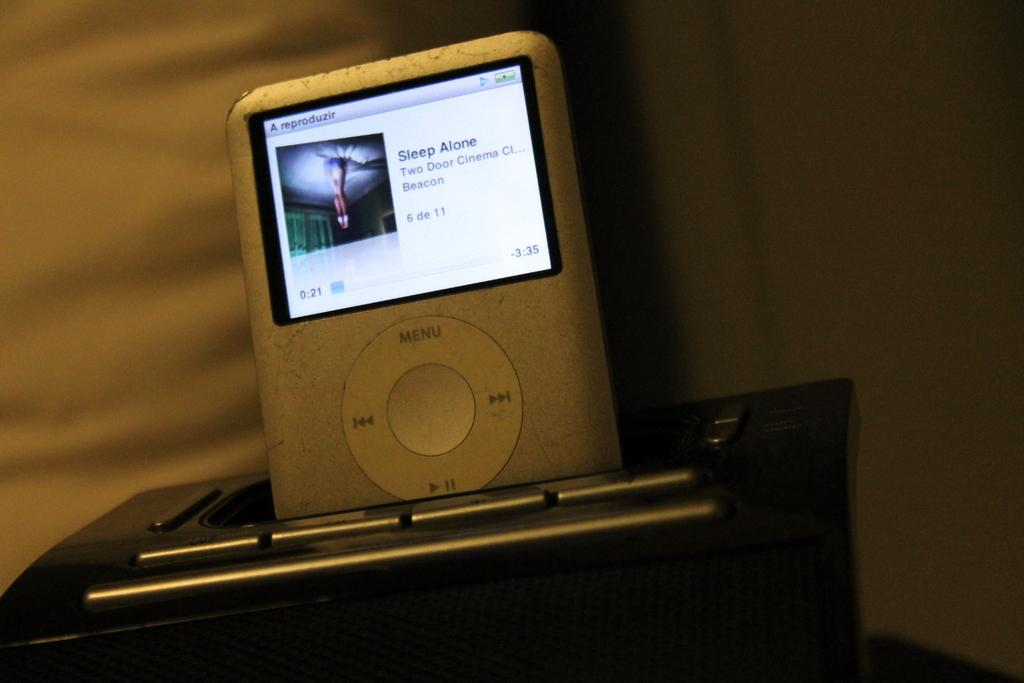What electronic device is visible in the image? There is an iPod in the image. Can you describe the positioning of the object in the image? The object is truncated towards the bottom of the image. What can be seen in the background of the image? The background of the image includes a wall that is truncated. What type of meal is being prepared by the farmer in the image? There is no farmer or meal preparation present in the image; it features an iPod and a truncated wall. Can you describe the cat's behavior in the image? There is no cat present in the image. 